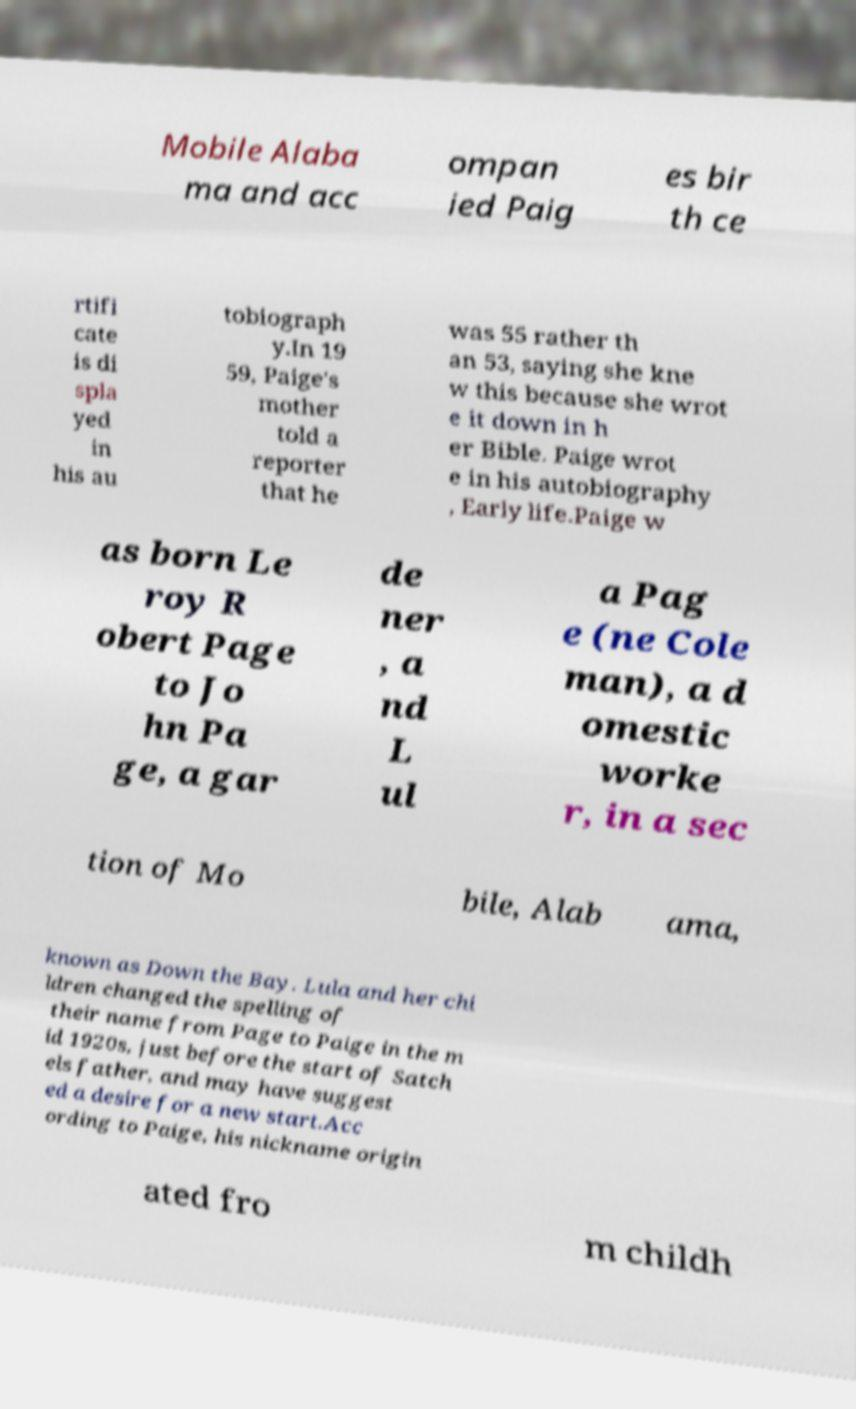For documentation purposes, I need the text within this image transcribed. Could you provide that? Mobile Alaba ma and acc ompan ied Paig es bir th ce rtifi cate is di spla yed in his au tobiograph y.In 19 59, Paige's mother told a reporter that he was 55 rather th an 53, saying she kne w this because she wrot e it down in h er Bible. Paige wrot e in his autobiography , Early life.Paige w as born Le roy R obert Page to Jo hn Pa ge, a gar de ner , a nd L ul a Pag e (ne Cole man), a d omestic worke r, in a sec tion of Mo bile, Alab ama, known as Down the Bay. Lula and her chi ldren changed the spelling of their name from Page to Paige in the m id 1920s, just before the start of Satch els father, and may have suggest ed a desire for a new start.Acc ording to Paige, his nickname origin ated fro m childh 